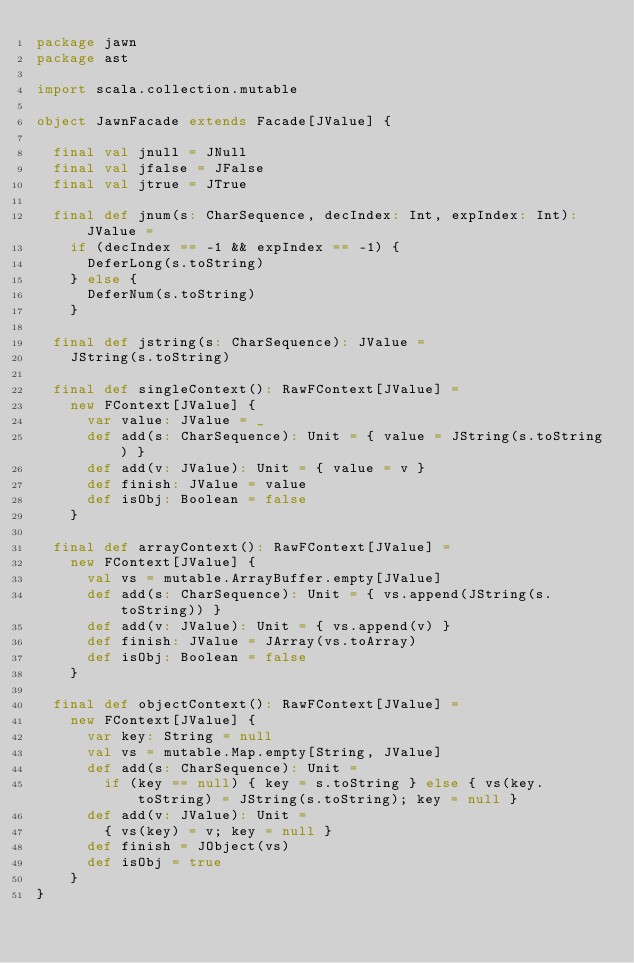Convert code to text. <code><loc_0><loc_0><loc_500><loc_500><_Scala_>package jawn
package ast

import scala.collection.mutable

object JawnFacade extends Facade[JValue] {

  final val jnull = JNull
  final val jfalse = JFalse
  final val jtrue = JTrue

  final def jnum(s: CharSequence, decIndex: Int, expIndex: Int): JValue =
    if (decIndex == -1 && expIndex == -1) {
      DeferLong(s.toString)
    } else {
      DeferNum(s.toString)
    }

  final def jstring(s: CharSequence): JValue =
    JString(s.toString)

  final def singleContext(): RawFContext[JValue] =
    new FContext[JValue] {
      var value: JValue = _
      def add(s: CharSequence): Unit = { value = JString(s.toString) }
      def add(v: JValue): Unit = { value = v }
      def finish: JValue = value
      def isObj: Boolean = false
    }

  final def arrayContext(): RawFContext[JValue] =
    new FContext[JValue] {
      val vs = mutable.ArrayBuffer.empty[JValue]
      def add(s: CharSequence): Unit = { vs.append(JString(s.toString)) }
      def add(v: JValue): Unit = { vs.append(v) }
      def finish: JValue = JArray(vs.toArray)
      def isObj: Boolean = false
    }

  final def objectContext(): RawFContext[JValue] =
    new FContext[JValue] {
      var key: String = null
      val vs = mutable.Map.empty[String, JValue]
      def add(s: CharSequence): Unit =
        if (key == null) { key = s.toString } else { vs(key.toString) = JString(s.toString); key = null }
      def add(v: JValue): Unit =
        { vs(key) = v; key = null }
      def finish = JObject(vs)
      def isObj = true
    }
}
</code> 